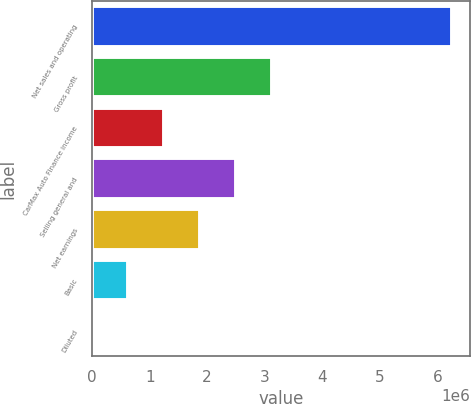Convert chart. <chart><loc_0><loc_0><loc_500><loc_500><bar_chart><fcel>Net sales and operating<fcel>Gross profit<fcel>CarMax Auto Finance income<fcel>Selling general and<fcel>Net earnings<fcel>Basic<fcel>Diluted<nl><fcel>6.25997e+06<fcel>3.12998e+06<fcel>1.25199e+06<fcel>2.50399e+06<fcel>1.87799e+06<fcel>625997<fcel>0.63<nl></chart> 